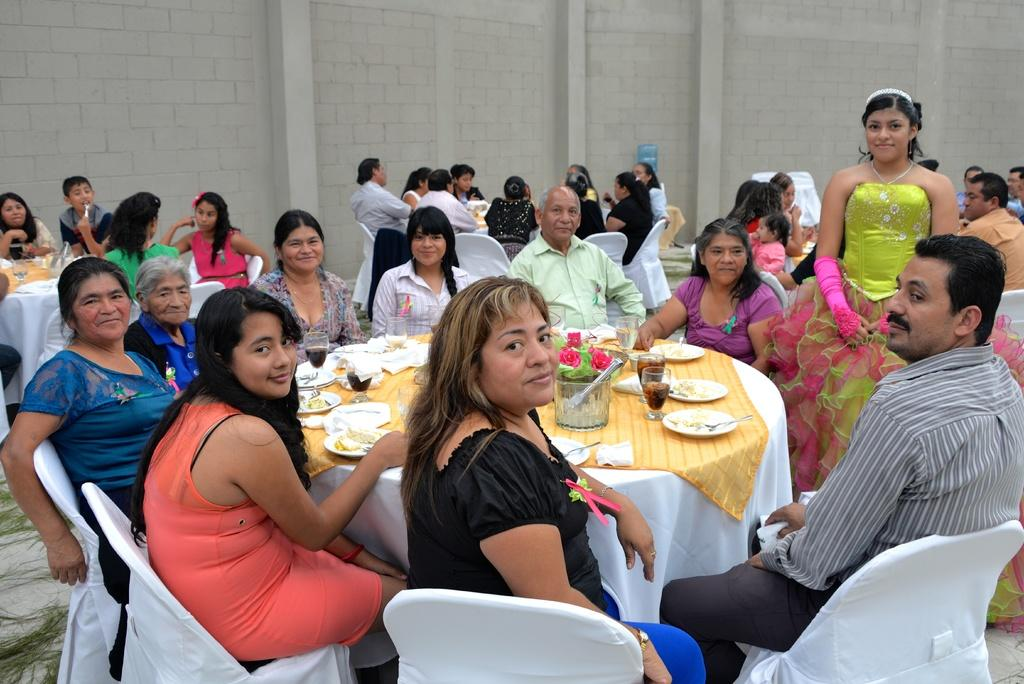What are the people in the image doing? The people in the image are sitting in groups. How are the people arranged in the image? The people are sitting around tables. What type of event is taking place in the image? The setting is a party. What type of jelly is being served at the party in the image? There is no mention of jelly being served at the party in the image. How many pigs are present at the party in the image? There are no pigs present at the party in the image. What part of the brain is being discussed by the people at the party in the image? There is no indication in the image that the people are discussing any part of the brain. 